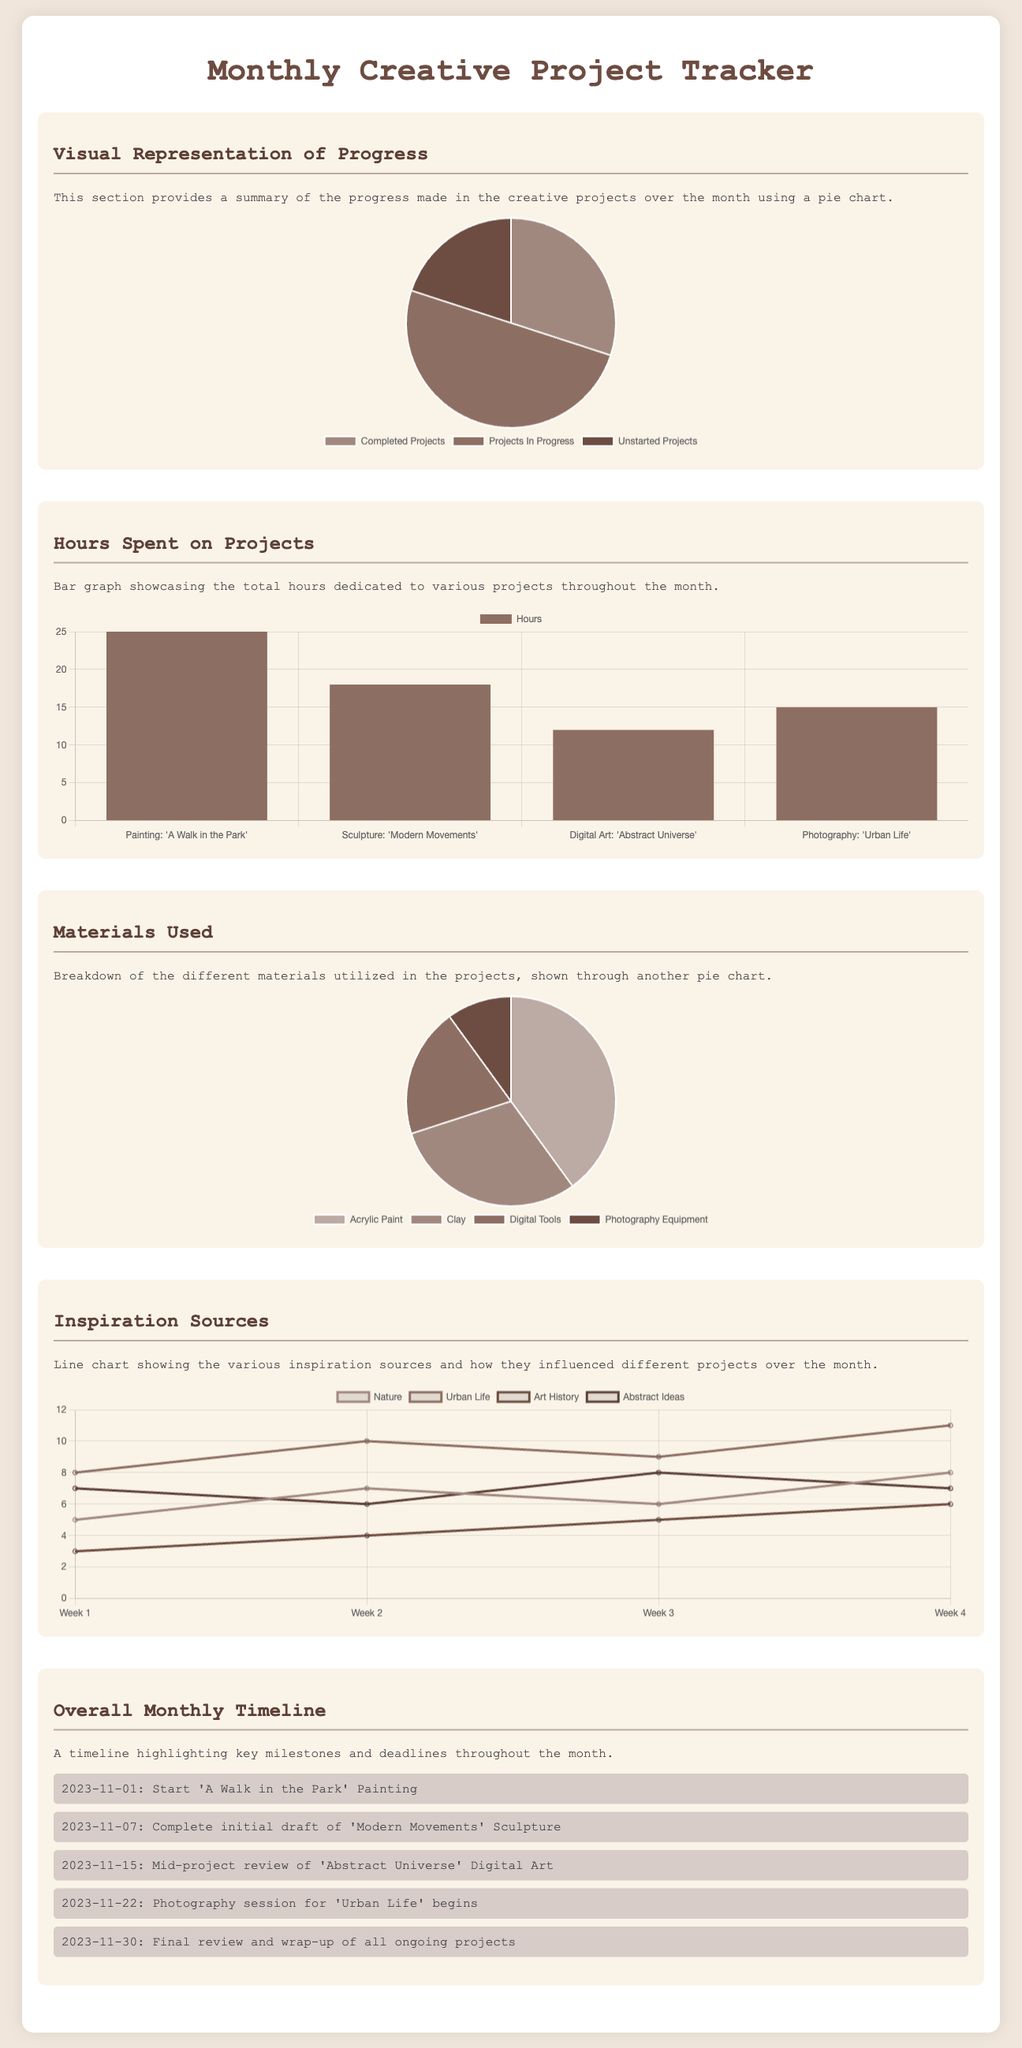What is the percentage of completed projects? The percentage of completed projects is displayed in the pie chart as a segment representing completed projects. In this case, it is 30%.
Answer: 30% How many total hours were spent on the sculpture project? The bar graph indicates that 18 hours were dedicated to the sculpture project titled "Modern Movements."
Answer: 18 What materials were used for digital art? The pie chart shows that digital tools were used for the digital art project, accounting for 20% of materials used.
Answer: Digital Tools Which project had the highest number of inspiration sources in week 2? The line chart indicates that the "Urban Life" inspiration source had the highest value at 10 during week 2.
Answer: Urban Life What is the total number of projects in progress? According to the pie chart, the projects in progress represent 50% of the total projects listed.
Answer: 50% Which week recorded the highest inspiration from nature? The line chart indicates that week 4 recorded the highest inspiration from nature with a value of 8.
Answer: Week 4 What is the start date of the painting project? The timeline notes that the painting project "A Walk in the Park" started on November 1, 2023.
Answer: November 1, 2023 How many different materials were listed in the document? The pie chart indicates that there are four different materials listed that were utilized in the projects.
Answer: Four What is the label for the lowest inspiration source in week 1? The line chart shows that the "Art History" inspiration source had the lowest value of 3 in week 1.
Answer: Art History 